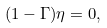Convert formula to latex. <formula><loc_0><loc_0><loc_500><loc_500>( 1 - \Gamma ) \eta = 0 ,</formula> 